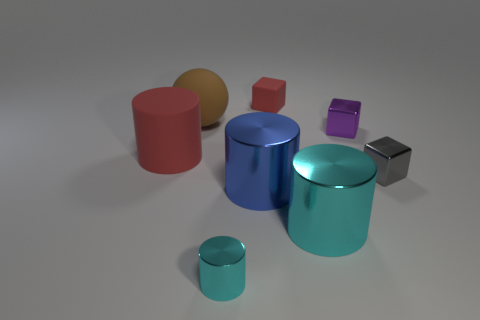There is a blue thing; how many matte objects are behind it?
Offer a very short reply. 3. There is a tiny thing to the left of the red object behind the red cylinder; what color is it?
Make the answer very short. Cyan. Is there any other thing that has the same shape as the small red matte object?
Your answer should be compact. Yes. Are there an equal number of large cylinders that are to the right of the small cyan shiny thing and big red cylinders that are in front of the gray shiny thing?
Your answer should be compact. No. What number of blocks are large matte objects or tiny purple rubber things?
Make the answer very short. 0. What number of other objects are there of the same material as the brown object?
Provide a succinct answer. 2. What shape is the red matte object that is on the right side of the big matte cylinder?
Ensure brevity in your answer.  Cube. What material is the cyan object on the left side of the red object that is behind the large brown sphere made of?
Give a very brief answer. Metal. Is the number of large metal objects that are on the left side of the blue metallic cylinder greater than the number of brown metallic blocks?
Make the answer very short. No. What number of other objects are there of the same color as the large matte cylinder?
Keep it short and to the point. 1. 